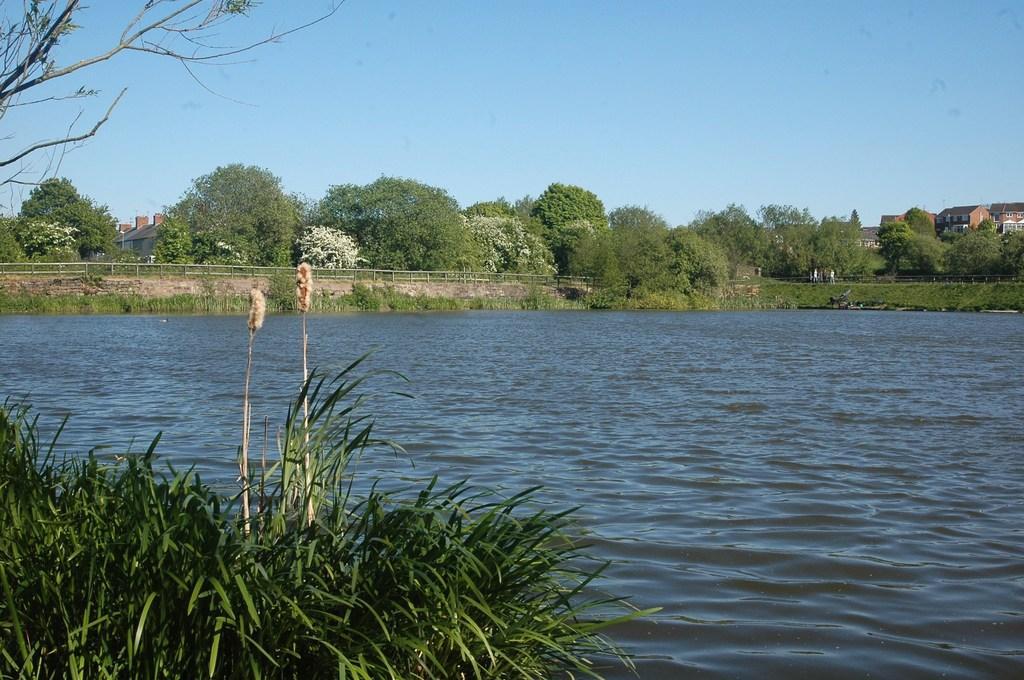Please provide a concise description of this image. In this picture we can see grass, flowers, water and truncated tree. In the background of the image we can see plants, grass, fence, trees, buildings and sky. 